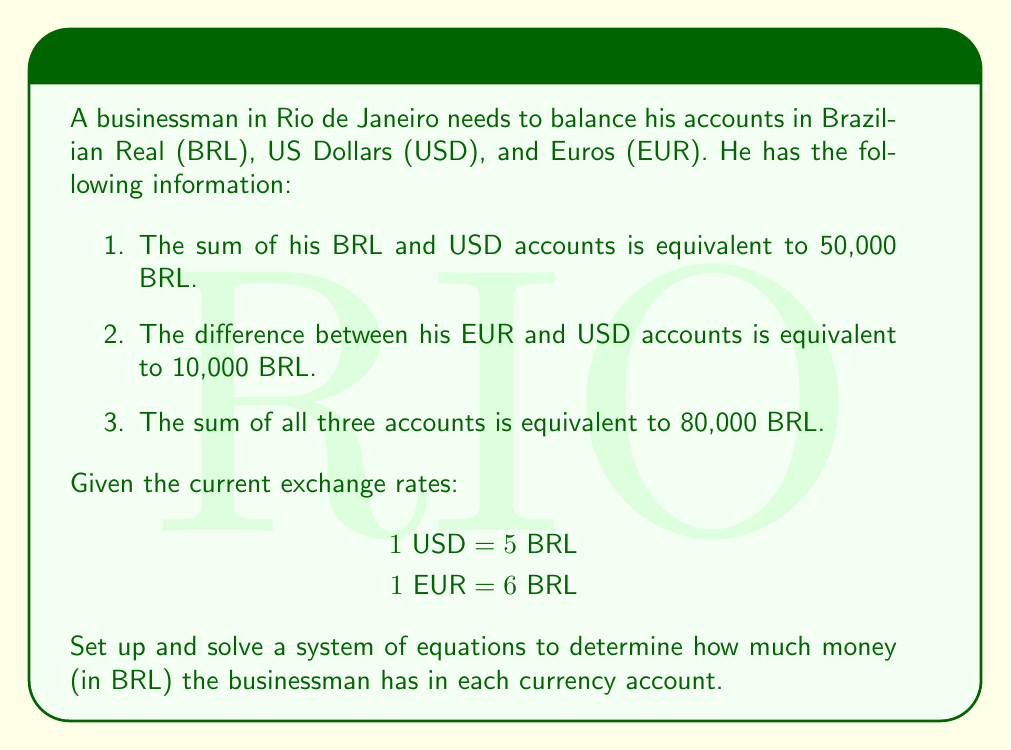Give your solution to this math problem. Let's approach this step-by-step:

1) Let's define our variables:
   $x$ = amount in BRL account
   $y$ = amount in USD account (in USD)
   $z$ = amount in EUR account (in EUR)

2) Now, let's set up our system of equations based on the given information:

   Equation 1: $x + 5y = 50000$ (sum of BRL and USD accounts in BRL)
   Equation 2: $6z - 5y = 10000$ (difference between EUR and USD accounts in BRL)
   Equation 3: $x + 5y + 6z = 80000$ (sum of all accounts in BRL)

3) We can solve this system using substitution method:

4) From Equation 1: $x = 50000 - 5y$

5) Substitute this into Equation 3:
   $(50000 - 5y) + 5y + 6z = 80000$
   $50000 + 6z = 80000$
   $6z = 30000$
   $z = 5000$

6) Now substitute $z = 5000$ into Equation 2:
   $6(5000) - 5y = 10000$
   $30000 - 5y = 10000$
   $-5y = -20000$
   $y = 4000$

7) Finally, we can find $x$ using Equation 1:
   $x + 5(4000) = 50000$
   $x + 20000 = 50000$
   $x = 30000$

8) Let's verify our solution satisfies all equations:
   Eq1: $30000 + 5(4000) = 50000$ ✓
   Eq2: $6(5000) - 5(4000) = 10000$ ✓
   Eq3: $30000 + 5(4000) + 6(5000) = 80000$ ✓
Answer: The businessman has:
BRL account: 30,000 BRL
USD account: 20,000 BRL (equivalent to 4,000 USD)
EUR account: 30,000 BRL (equivalent to 5,000 EUR) 